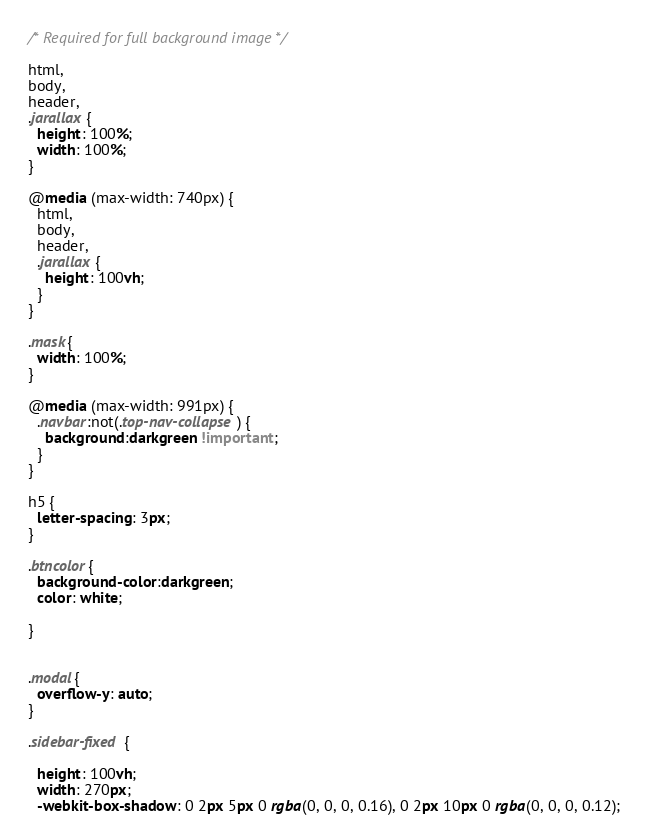<code> <loc_0><loc_0><loc_500><loc_500><_CSS_>/* Required for full background image */

html,
body,
header,
.jarallax {
  height: 100%;
  width: 100%;
}

@media (max-width: 740px) {
  html,
  body,
  header,
  .jarallax {
    height: 100vh;
  }
}

.mask{
  width: 100%;
}

@media (max-width: 991px) {
  .navbar:not(.top-nav-collapse) {
    background:darkgreen !important;
  }
}

h5 {
  letter-spacing: 3px;
}

.btncolor{
  background-color:darkgreen;
  color: white;
  
}


.modal{
  overflow-y: auto;
}

.sidebar-fixed {
   
  height: 100vh;
  width: 270px;
  -webkit-box-shadow: 0 2px 5px 0 rgba(0, 0, 0, 0.16), 0 2px 10px 0 rgba(0, 0, 0, 0.12);</code> 